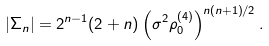Convert formula to latex. <formula><loc_0><loc_0><loc_500><loc_500>| \Sigma _ { n } | = 2 ^ { n - 1 } ( 2 + n ) \left ( \sigma ^ { 2 } \rho ^ { ( 4 ) } _ { 0 } \right ) ^ { { n ( n + 1 ) } / { 2 } } .</formula> 